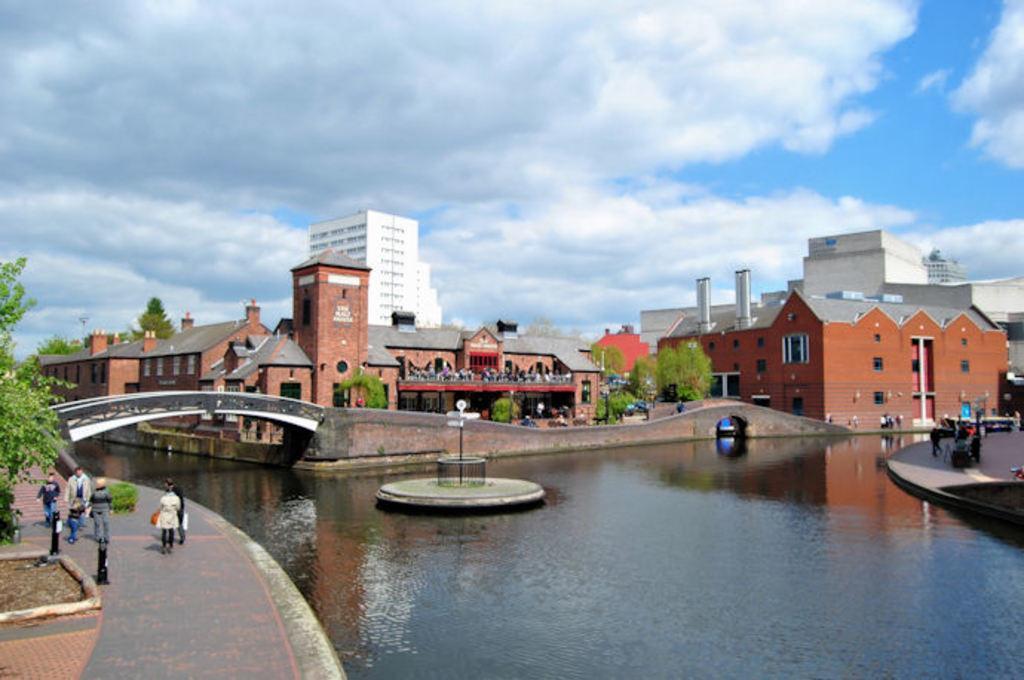Can you describe this image briefly? At the center of the image there is a building, in front of the building there is a lake. On the right and left side of the image there is a path of a road and some people are walking on it. In the background there is a sky. 